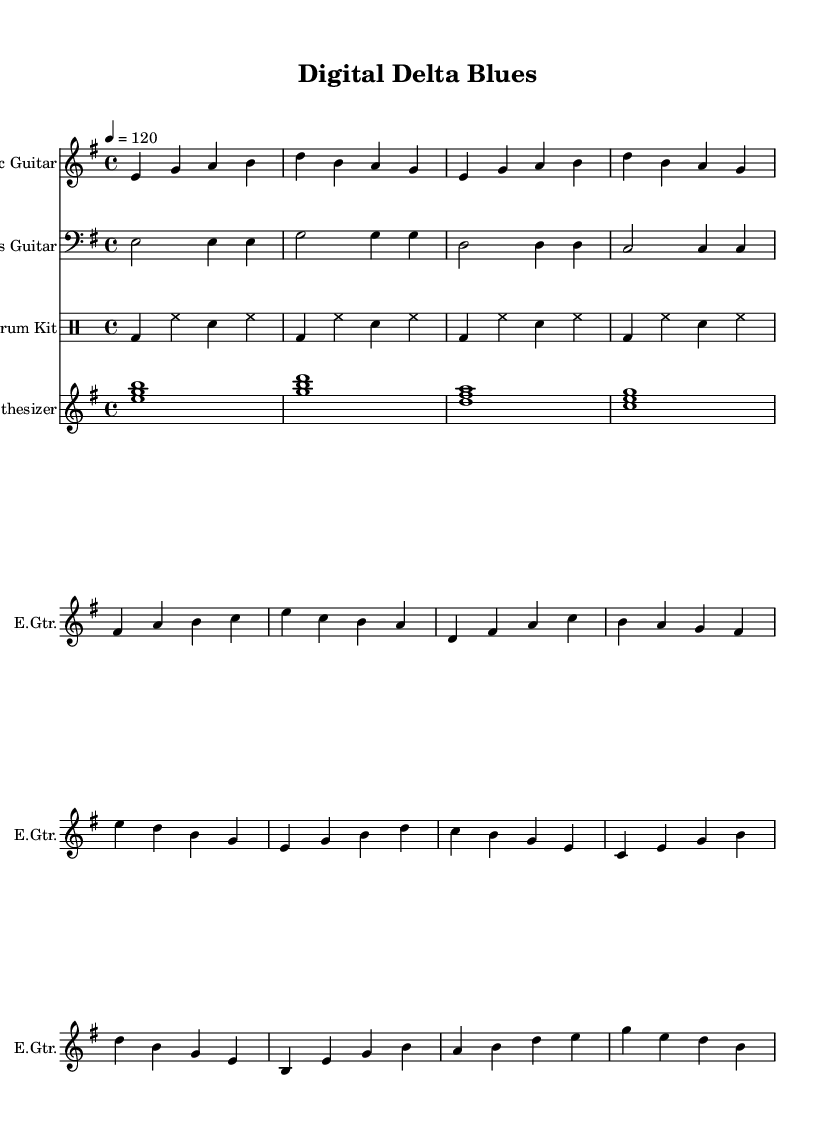What is the key signature of this music? The key signature is E minor, which has one sharp (F#). It can be determined by looking at the key signature indicator at the beginning of the staff, which shows the sharp mark on the F line.
Answer: E minor What is the time signature of this music? The time signature is 4/4, indicated at the beginning of the score. This means there are four beats per measure and the quarter note gets one beat.
Answer: 4/4 What is the tempo of the piece? The tempo is 120 beats per minute, as specified at the beginning of the score with the marking indicating the tempo in quarter note beats (4 = 120).
Answer: 120 Which instrument is playing the bass line? The bass line is played by the Bass Guitar, which is clearly labeled at the beginning of that staff in the score.
Answer: Bass Guitar In the melody of the electric guitar, how many bars are there in the verse section? The verse melody of the electric guitar contains 8 bars. By counting the groups of four beats, one can see there are two full measures (4 bars each) before the transition to the chorus.
Answer: 8 bars What unique technique is used in the synthesizer part? A synthesizer pad is utilized in the piece, which is characterized by sustained chords. The chords played as full-note measures provide a harmonic background that complements the electric blues theme.
Answer: Synth pad How does the drum pattern synchronize with the guitar melody? The drum pattern has a consistent beat that complements the rhythm of the guitar melody; it follows a basic rock pattern that provides a steady pulse, aligning well with the guitar's phrasing. This creates an effective rhythmic base for the style of electric blues presented.
Answer: Synchronizes rhythmically 